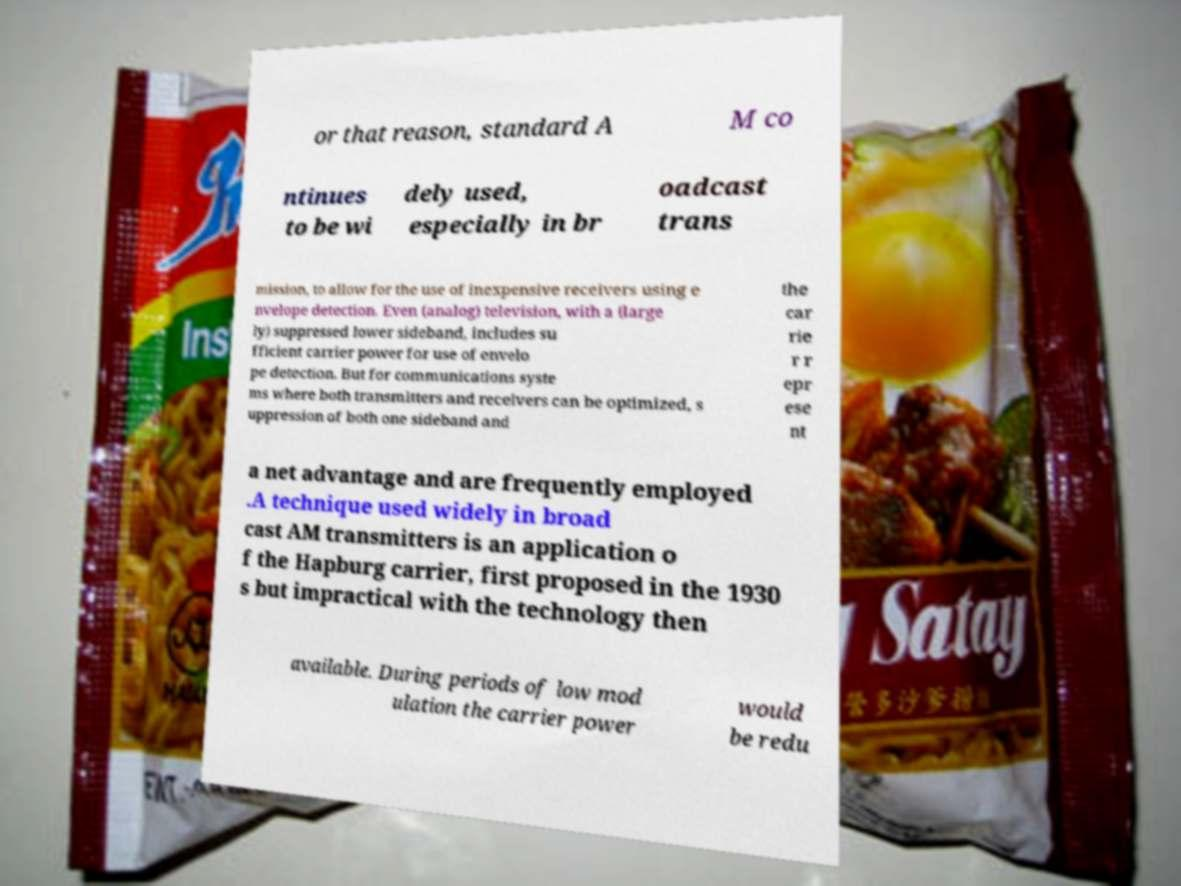I need the written content from this picture converted into text. Can you do that? or that reason, standard A M co ntinues to be wi dely used, especially in br oadcast trans mission, to allow for the use of inexpensive receivers using e nvelope detection. Even (analog) television, with a (large ly) suppressed lower sideband, includes su fficient carrier power for use of envelo pe detection. But for communications syste ms where both transmitters and receivers can be optimized, s uppression of both one sideband and the car rie r r epr ese nt a net advantage and are frequently employed .A technique used widely in broad cast AM transmitters is an application o f the Hapburg carrier, first proposed in the 1930 s but impractical with the technology then available. During periods of low mod ulation the carrier power would be redu 